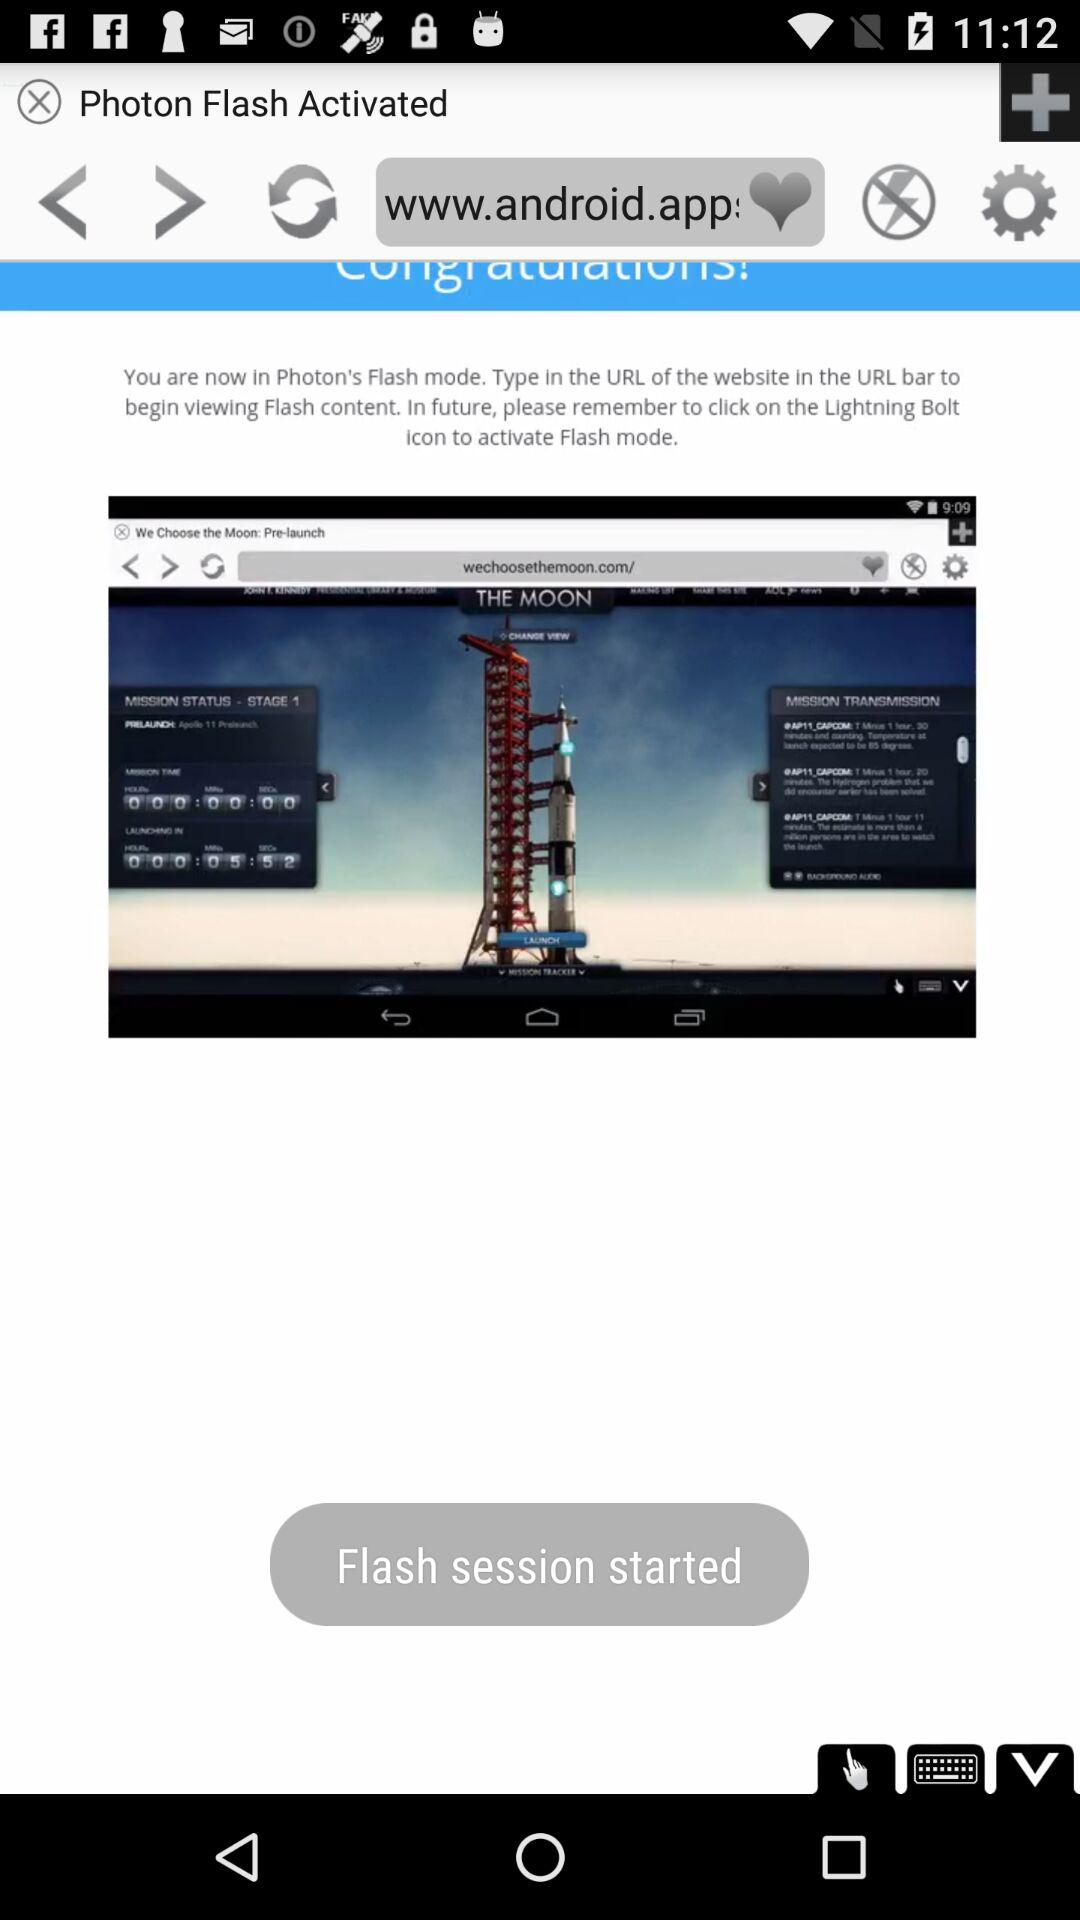What session has been started? The session "Flash" has been started. 